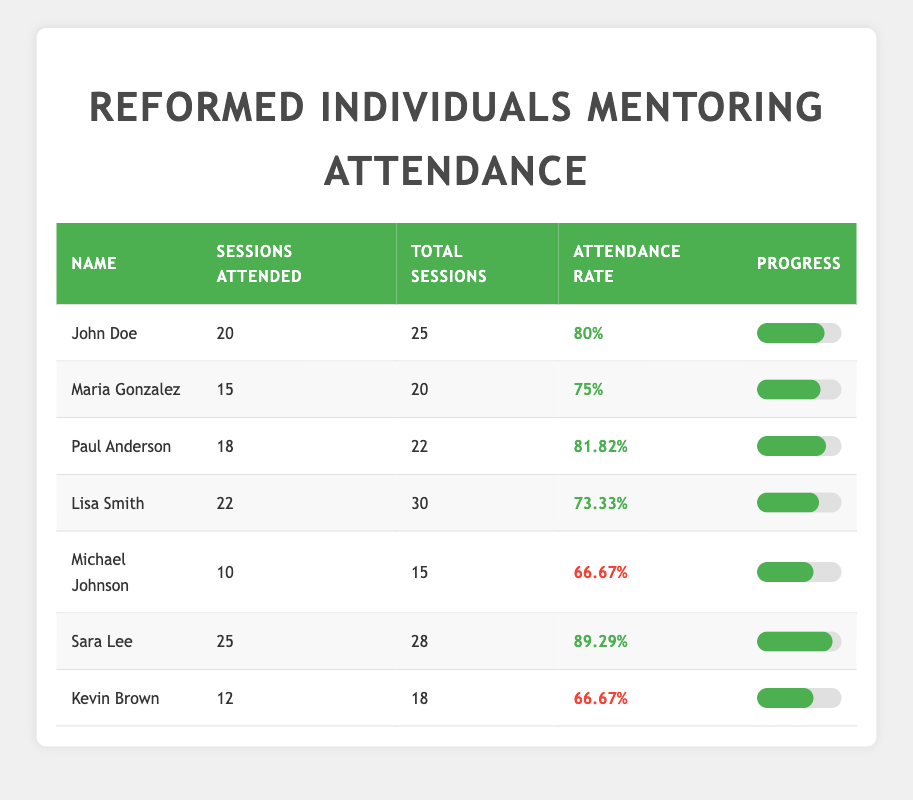What is the attendance rate of Sara Lee? From the table, the attendance rate column shows that Sara Lee's attendance rate is 89.29%.
Answer: 89.29% Who attended the most mentoring sessions? By looking at the 'Sessions Attended' column, Sara Lee attended 25 sessions, which is the highest among all individuals listed.
Answer: Sara Lee What is the average attendance rate of the individuals listed? To find the average attendance rate, sum the attendance rates: 80 + 75 + 81.82 + 73.33 + 66.67 + 89.29 + 66.67 = 532.78. Then, divide by the number of individuals, which is 7. So, 532.78/7 = 76.11.
Answer: 76.11 Did Michael Johnson attend more sessions than Lisa Smith? Michael Johnson attended 10 sessions, while Lisa Smith attended 22. Therefore, Michael Johnson did not attend more sessions than Lisa Smith.
Answer: No What is the difference in attendance rates between the highest and lowest? The highest attendance rate is 89.29% (Sara Lee) and the lowest is 66.67% (Michael Johnson and Kevin Brown). The difference is 89.29 - 66.67 = 22.62%.
Answer: 22.62% Which individuals have an attendance rate below 75%? Looking at the attendance rates, both Michael Johnson and Kevin Brown have an attendance rate of 66.67%, which is below 75%.
Answer: Michael Johnson and Kevin Brown How many total sessions were attended by Paul Anderson and Lisa Smith combined? Paul Anderson attended 18 sessions and Lisa Smith attended 22 sessions. Adding these together: 18 + 22 = 40.
Answer: 40 What is the total number of mentoring sessions attended by all individuals? To find the total sessions attended, sum the 'Sessions Attended' column: 20 + 15 + 18 + 22 + 10 + 25 + 12 = 132.
Answer: 132 